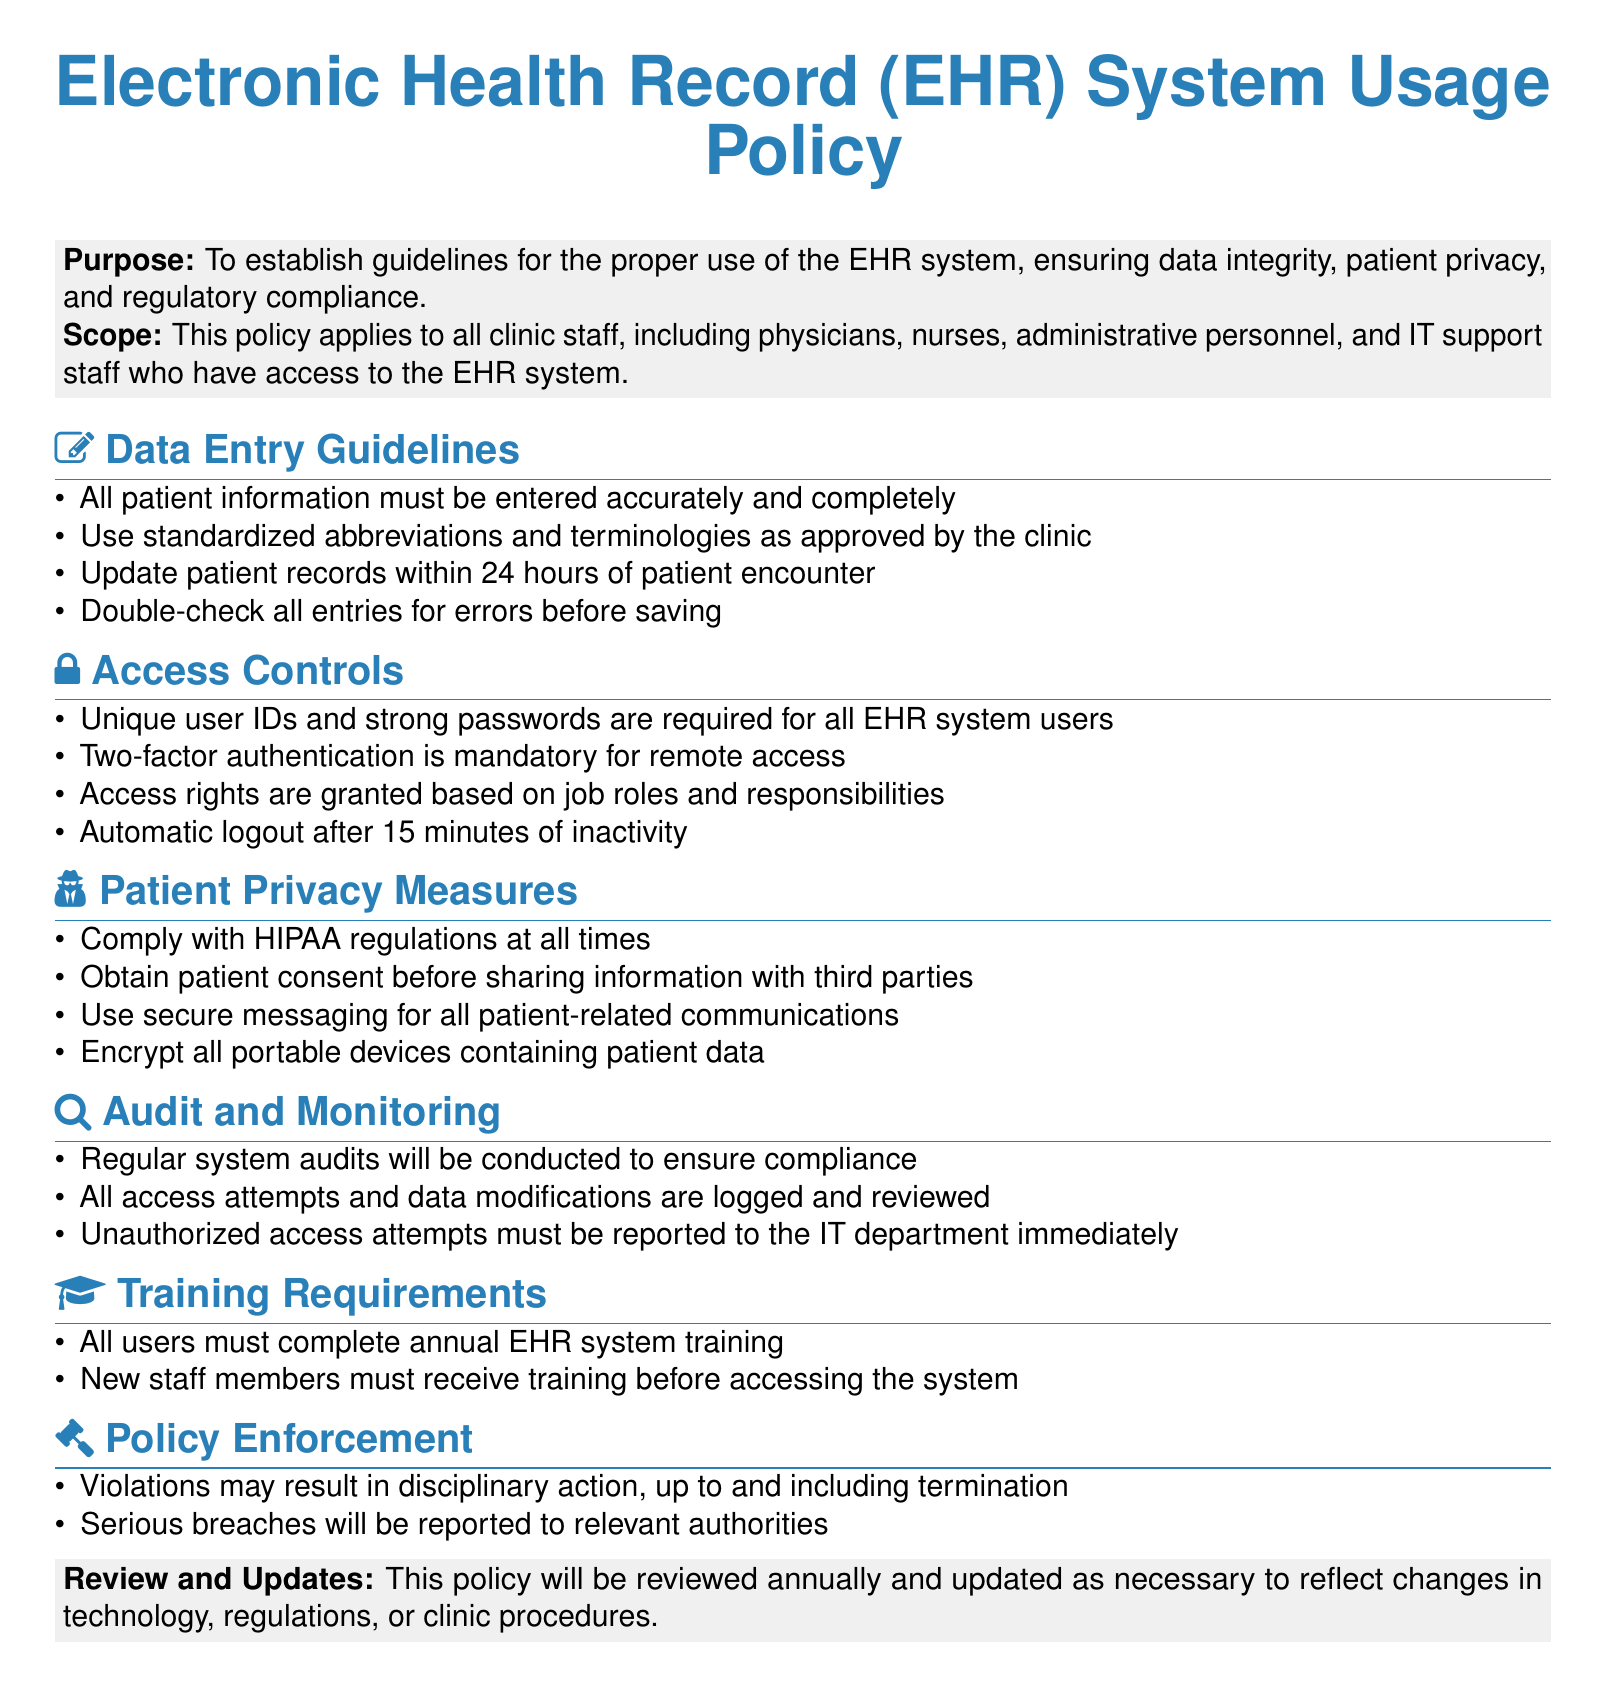What is the purpose of the EHR policy? The purpose is to establish guidelines for the proper use of the EHR system, ensuring data integrity, patient privacy, and regulatory compliance.
Answer: To establish guidelines for the proper use of the EHR system, ensuring data integrity, patient privacy, and regulatory compliance Who must complete annual EHR training? All users must complete annual EHR system training according to the training requirements outlined in the document.
Answer: All users What are the username requirements for system users? Unique user IDs and strong passwords are required for all EHR system users as stated in the access controls section.
Answer: Unique user IDs and strong passwords What is the automatic logout duration for inactivity? The document specifies an automatic logout after 15 minutes of inactivity in the access controls section.
Answer: 15 minutes What must be obtained before sharing patient information with third parties? The patient consent is required before sharing information with third parties as mentioned under patient privacy measures.
Answer: Patient consent How often will the policy be reviewed? The document states that the policy will be reviewed annually.
Answer: Annually What disciplinary action may occur for policy violations? Violations may result in disciplinary action, up to and including termination, as indicated in the policy enforcement section.
Answer: Termination What type of communication should be used for patient-related messages? Secure messaging is recommended for all patient-related communications in the patient privacy measures.
Answer: Secure messaging 